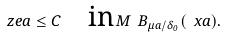<formula> <loc_0><loc_0><loc_500><loc_500>\ z e a \leq C \quad \text {in} \, M \ B _ { \mu a / \delta _ { 0 } } ( \ x a ) .</formula> 